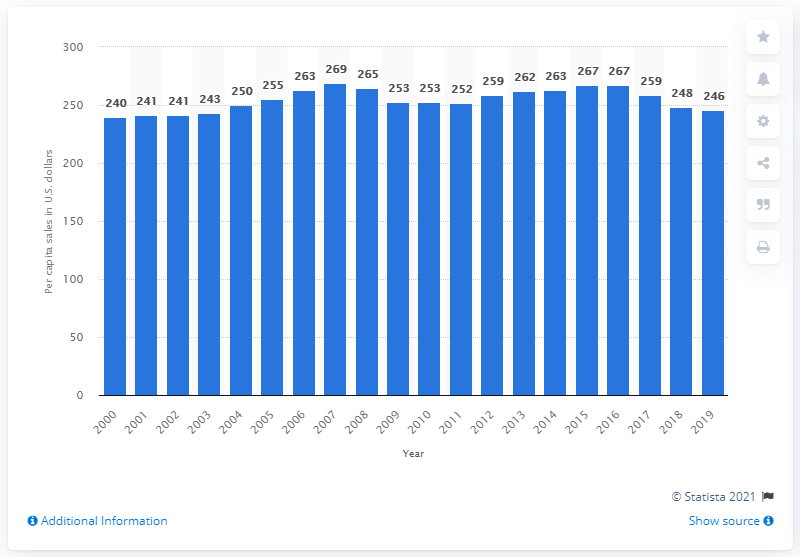Give some essential details in this illustration. In 2019, the per capita sales of sporting goods, hobby, musical instrument, and book stores were 250. 